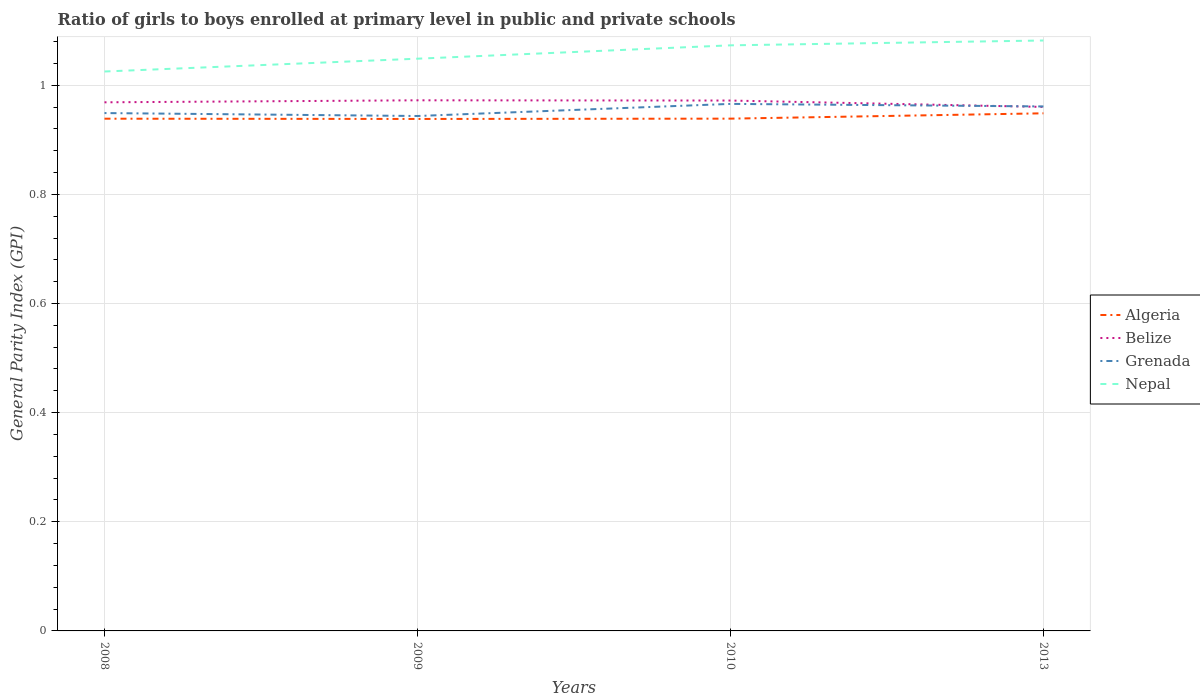Does the line corresponding to Algeria intersect with the line corresponding to Grenada?
Provide a succinct answer. No. Is the number of lines equal to the number of legend labels?
Make the answer very short. Yes. Across all years, what is the maximum general parity index in Nepal?
Your answer should be very brief. 1.03. What is the total general parity index in Grenada in the graph?
Make the answer very short. 0. What is the difference between the highest and the second highest general parity index in Belize?
Give a very brief answer. 0.01. What is the difference between the highest and the lowest general parity index in Nepal?
Offer a very short reply. 2. How many years are there in the graph?
Make the answer very short. 4. Does the graph contain any zero values?
Offer a very short reply. No. Does the graph contain grids?
Provide a short and direct response. Yes. Where does the legend appear in the graph?
Offer a very short reply. Center right. How many legend labels are there?
Offer a terse response. 4. What is the title of the graph?
Offer a very short reply. Ratio of girls to boys enrolled at primary level in public and private schools. Does "Pakistan" appear as one of the legend labels in the graph?
Give a very brief answer. No. What is the label or title of the Y-axis?
Make the answer very short. General Parity Index (GPI). What is the General Parity Index (GPI) in Algeria in 2008?
Offer a terse response. 0.94. What is the General Parity Index (GPI) of Belize in 2008?
Make the answer very short. 0.97. What is the General Parity Index (GPI) in Grenada in 2008?
Your response must be concise. 0.95. What is the General Parity Index (GPI) in Nepal in 2008?
Offer a very short reply. 1.03. What is the General Parity Index (GPI) in Algeria in 2009?
Your answer should be compact. 0.94. What is the General Parity Index (GPI) in Belize in 2009?
Give a very brief answer. 0.97. What is the General Parity Index (GPI) in Grenada in 2009?
Keep it short and to the point. 0.94. What is the General Parity Index (GPI) of Nepal in 2009?
Your answer should be compact. 1.05. What is the General Parity Index (GPI) of Algeria in 2010?
Offer a very short reply. 0.94. What is the General Parity Index (GPI) of Belize in 2010?
Provide a succinct answer. 0.97. What is the General Parity Index (GPI) in Grenada in 2010?
Provide a succinct answer. 0.97. What is the General Parity Index (GPI) in Nepal in 2010?
Offer a very short reply. 1.07. What is the General Parity Index (GPI) of Algeria in 2013?
Your answer should be very brief. 0.95. What is the General Parity Index (GPI) of Belize in 2013?
Keep it short and to the point. 0.96. What is the General Parity Index (GPI) of Grenada in 2013?
Make the answer very short. 0.96. What is the General Parity Index (GPI) of Nepal in 2013?
Provide a short and direct response. 1.08. Across all years, what is the maximum General Parity Index (GPI) of Algeria?
Provide a succinct answer. 0.95. Across all years, what is the maximum General Parity Index (GPI) of Belize?
Your answer should be compact. 0.97. Across all years, what is the maximum General Parity Index (GPI) of Grenada?
Make the answer very short. 0.97. Across all years, what is the maximum General Parity Index (GPI) of Nepal?
Provide a succinct answer. 1.08. Across all years, what is the minimum General Parity Index (GPI) of Algeria?
Give a very brief answer. 0.94. Across all years, what is the minimum General Parity Index (GPI) in Belize?
Your answer should be compact. 0.96. Across all years, what is the minimum General Parity Index (GPI) in Grenada?
Keep it short and to the point. 0.94. Across all years, what is the minimum General Parity Index (GPI) of Nepal?
Make the answer very short. 1.03. What is the total General Parity Index (GPI) in Algeria in the graph?
Your response must be concise. 3.76. What is the total General Parity Index (GPI) in Belize in the graph?
Provide a short and direct response. 3.87. What is the total General Parity Index (GPI) in Grenada in the graph?
Your answer should be compact. 3.82. What is the total General Parity Index (GPI) of Nepal in the graph?
Make the answer very short. 4.23. What is the difference between the General Parity Index (GPI) of Belize in 2008 and that in 2009?
Ensure brevity in your answer.  -0. What is the difference between the General Parity Index (GPI) of Grenada in 2008 and that in 2009?
Your response must be concise. 0.01. What is the difference between the General Parity Index (GPI) of Nepal in 2008 and that in 2009?
Your answer should be compact. -0.02. What is the difference between the General Parity Index (GPI) in Algeria in 2008 and that in 2010?
Your answer should be compact. -0. What is the difference between the General Parity Index (GPI) in Belize in 2008 and that in 2010?
Ensure brevity in your answer.  -0. What is the difference between the General Parity Index (GPI) of Grenada in 2008 and that in 2010?
Ensure brevity in your answer.  -0.02. What is the difference between the General Parity Index (GPI) in Nepal in 2008 and that in 2010?
Keep it short and to the point. -0.05. What is the difference between the General Parity Index (GPI) of Algeria in 2008 and that in 2013?
Ensure brevity in your answer.  -0.01. What is the difference between the General Parity Index (GPI) of Belize in 2008 and that in 2013?
Your response must be concise. 0.01. What is the difference between the General Parity Index (GPI) of Grenada in 2008 and that in 2013?
Provide a short and direct response. -0.01. What is the difference between the General Parity Index (GPI) in Nepal in 2008 and that in 2013?
Offer a terse response. -0.06. What is the difference between the General Parity Index (GPI) in Algeria in 2009 and that in 2010?
Keep it short and to the point. -0. What is the difference between the General Parity Index (GPI) of Grenada in 2009 and that in 2010?
Offer a terse response. -0.02. What is the difference between the General Parity Index (GPI) of Nepal in 2009 and that in 2010?
Your response must be concise. -0.02. What is the difference between the General Parity Index (GPI) in Algeria in 2009 and that in 2013?
Give a very brief answer. -0.01. What is the difference between the General Parity Index (GPI) in Belize in 2009 and that in 2013?
Offer a very short reply. 0.01. What is the difference between the General Parity Index (GPI) in Grenada in 2009 and that in 2013?
Make the answer very short. -0.02. What is the difference between the General Parity Index (GPI) in Nepal in 2009 and that in 2013?
Offer a terse response. -0.03. What is the difference between the General Parity Index (GPI) of Algeria in 2010 and that in 2013?
Keep it short and to the point. -0.01. What is the difference between the General Parity Index (GPI) of Belize in 2010 and that in 2013?
Make the answer very short. 0.01. What is the difference between the General Parity Index (GPI) in Grenada in 2010 and that in 2013?
Your answer should be very brief. 0. What is the difference between the General Parity Index (GPI) of Nepal in 2010 and that in 2013?
Your answer should be compact. -0.01. What is the difference between the General Parity Index (GPI) of Algeria in 2008 and the General Parity Index (GPI) of Belize in 2009?
Ensure brevity in your answer.  -0.03. What is the difference between the General Parity Index (GPI) in Algeria in 2008 and the General Parity Index (GPI) in Grenada in 2009?
Keep it short and to the point. -0. What is the difference between the General Parity Index (GPI) of Algeria in 2008 and the General Parity Index (GPI) of Nepal in 2009?
Provide a succinct answer. -0.11. What is the difference between the General Parity Index (GPI) of Belize in 2008 and the General Parity Index (GPI) of Grenada in 2009?
Your answer should be compact. 0.03. What is the difference between the General Parity Index (GPI) in Belize in 2008 and the General Parity Index (GPI) in Nepal in 2009?
Ensure brevity in your answer.  -0.08. What is the difference between the General Parity Index (GPI) of Grenada in 2008 and the General Parity Index (GPI) of Nepal in 2009?
Provide a short and direct response. -0.1. What is the difference between the General Parity Index (GPI) of Algeria in 2008 and the General Parity Index (GPI) of Belize in 2010?
Give a very brief answer. -0.03. What is the difference between the General Parity Index (GPI) in Algeria in 2008 and the General Parity Index (GPI) in Grenada in 2010?
Offer a very short reply. -0.03. What is the difference between the General Parity Index (GPI) of Algeria in 2008 and the General Parity Index (GPI) of Nepal in 2010?
Offer a terse response. -0.13. What is the difference between the General Parity Index (GPI) of Belize in 2008 and the General Parity Index (GPI) of Grenada in 2010?
Provide a succinct answer. 0. What is the difference between the General Parity Index (GPI) of Belize in 2008 and the General Parity Index (GPI) of Nepal in 2010?
Keep it short and to the point. -0.1. What is the difference between the General Parity Index (GPI) in Grenada in 2008 and the General Parity Index (GPI) in Nepal in 2010?
Keep it short and to the point. -0.12. What is the difference between the General Parity Index (GPI) in Algeria in 2008 and the General Parity Index (GPI) in Belize in 2013?
Provide a short and direct response. -0.02. What is the difference between the General Parity Index (GPI) of Algeria in 2008 and the General Parity Index (GPI) of Grenada in 2013?
Offer a very short reply. -0.02. What is the difference between the General Parity Index (GPI) in Algeria in 2008 and the General Parity Index (GPI) in Nepal in 2013?
Your response must be concise. -0.14. What is the difference between the General Parity Index (GPI) in Belize in 2008 and the General Parity Index (GPI) in Grenada in 2013?
Provide a short and direct response. 0.01. What is the difference between the General Parity Index (GPI) of Belize in 2008 and the General Parity Index (GPI) of Nepal in 2013?
Offer a terse response. -0.11. What is the difference between the General Parity Index (GPI) in Grenada in 2008 and the General Parity Index (GPI) in Nepal in 2013?
Offer a terse response. -0.13. What is the difference between the General Parity Index (GPI) of Algeria in 2009 and the General Parity Index (GPI) of Belize in 2010?
Ensure brevity in your answer.  -0.03. What is the difference between the General Parity Index (GPI) in Algeria in 2009 and the General Parity Index (GPI) in Grenada in 2010?
Your answer should be compact. -0.03. What is the difference between the General Parity Index (GPI) in Algeria in 2009 and the General Parity Index (GPI) in Nepal in 2010?
Ensure brevity in your answer.  -0.13. What is the difference between the General Parity Index (GPI) in Belize in 2009 and the General Parity Index (GPI) in Grenada in 2010?
Provide a succinct answer. 0.01. What is the difference between the General Parity Index (GPI) of Belize in 2009 and the General Parity Index (GPI) of Nepal in 2010?
Provide a succinct answer. -0.1. What is the difference between the General Parity Index (GPI) in Grenada in 2009 and the General Parity Index (GPI) in Nepal in 2010?
Offer a very short reply. -0.13. What is the difference between the General Parity Index (GPI) of Algeria in 2009 and the General Parity Index (GPI) of Belize in 2013?
Offer a terse response. -0.02. What is the difference between the General Parity Index (GPI) in Algeria in 2009 and the General Parity Index (GPI) in Grenada in 2013?
Make the answer very short. -0.02. What is the difference between the General Parity Index (GPI) in Algeria in 2009 and the General Parity Index (GPI) in Nepal in 2013?
Provide a succinct answer. -0.14. What is the difference between the General Parity Index (GPI) in Belize in 2009 and the General Parity Index (GPI) in Grenada in 2013?
Make the answer very short. 0.01. What is the difference between the General Parity Index (GPI) in Belize in 2009 and the General Parity Index (GPI) in Nepal in 2013?
Your response must be concise. -0.11. What is the difference between the General Parity Index (GPI) of Grenada in 2009 and the General Parity Index (GPI) of Nepal in 2013?
Keep it short and to the point. -0.14. What is the difference between the General Parity Index (GPI) in Algeria in 2010 and the General Parity Index (GPI) in Belize in 2013?
Ensure brevity in your answer.  -0.02. What is the difference between the General Parity Index (GPI) in Algeria in 2010 and the General Parity Index (GPI) in Grenada in 2013?
Provide a succinct answer. -0.02. What is the difference between the General Parity Index (GPI) in Algeria in 2010 and the General Parity Index (GPI) in Nepal in 2013?
Provide a succinct answer. -0.14. What is the difference between the General Parity Index (GPI) of Belize in 2010 and the General Parity Index (GPI) of Grenada in 2013?
Offer a very short reply. 0.01. What is the difference between the General Parity Index (GPI) of Belize in 2010 and the General Parity Index (GPI) of Nepal in 2013?
Offer a very short reply. -0.11. What is the difference between the General Parity Index (GPI) in Grenada in 2010 and the General Parity Index (GPI) in Nepal in 2013?
Make the answer very short. -0.12. What is the average General Parity Index (GPI) in Algeria per year?
Provide a succinct answer. 0.94. What is the average General Parity Index (GPI) of Belize per year?
Your answer should be very brief. 0.97. What is the average General Parity Index (GPI) of Grenada per year?
Ensure brevity in your answer.  0.95. What is the average General Parity Index (GPI) in Nepal per year?
Provide a short and direct response. 1.06. In the year 2008, what is the difference between the General Parity Index (GPI) of Algeria and General Parity Index (GPI) of Belize?
Provide a short and direct response. -0.03. In the year 2008, what is the difference between the General Parity Index (GPI) of Algeria and General Parity Index (GPI) of Grenada?
Make the answer very short. -0.01. In the year 2008, what is the difference between the General Parity Index (GPI) in Algeria and General Parity Index (GPI) in Nepal?
Make the answer very short. -0.09. In the year 2008, what is the difference between the General Parity Index (GPI) of Belize and General Parity Index (GPI) of Grenada?
Your answer should be very brief. 0.02. In the year 2008, what is the difference between the General Parity Index (GPI) in Belize and General Parity Index (GPI) in Nepal?
Your response must be concise. -0.06. In the year 2008, what is the difference between the General Parity Index (GPI) in Grenada and General Parity Index (GPI) in Nepal?
Keep it short and to the point. -0.08. In the year 2009, what is the difference between the General Parity Index (GPI) of Algeria and General Parity Index (GPI) of Belize?
Your response must be concise. -0.03. In the year 2009, what is the difference between the General Parity Index (GPI) of Algeria and General Parity Index (GPI) of Grenada?
Make the answer very short. -0.01. In the year 2009, what is the difference between the General Parity Index (GPI) of Algeria and General Parity Index (GPI) of Nepal?
Ensure brevity in your answer.  -0.11. In the year 2009, what is the difference between the General Parity Index (GPI) of Belize and General Parity Index (GPI) of Grenada?
Provide a short and direct response. 0.03. In the year 2009, what is the difference between the General Parity Index (GPI) in Belize and General Parity Index (GPI) in Nepal?
Your answer should be very brief. -0.08. In the year 2009, what is the difference between the General Parity Index (GPI) of Grenada and General Parity Index (GPI) of Nepal?
Your answer should be very brief. -0.1. In the year 2010, what is the difference between the General Parity Index (GPI) of Algeria and General Parity Index (GPI) of Belize?
Provide a short and direct response. -0.03. In the year 2010, what is the difference between the General Parity Index (GPI) in Algeria and General Parity Index (GPI) in Grenada?
Make the answer very short. -0.03. In the year 2010, what is the difference between the General Parity Index (GPI) of Algeria and General Parity Index (GPI) of Nepal?
Offer a terse response. -0.13. In the year 2010, what is the difference between the General Parity Index (GPI) in Belize and General Parity Index (GPI) in Grenada?
Keep it short and to the point. 0.01. In the year 2010, what is the difference between the General Parity Index (GPI) of Belize and General Parity Index (GPI) of Nepal?
Ensure brevity in your answer.  -0.1. In the year 2010, what is the difference between the General Parity Index (GPI) in Grenada and General Parity Index (GPI) in Nepal?
Provide a succinct answer. -0.11. In the year 2013, what is the difference between the General Parity Index (GPI) in Algeria and General Parity Index (GPI) in Belize?
Keep it short and to the point. -0.01. In the year 2013, what is the difference between the General Parity Index (GPI) of Algeria and General Parity Index (GPI) of Grenada?
Make the answer very short. -0.01. In the year 2013, what is the difference between the General Parity Index (GPI) in Algeria and General Parity Index (GPI) in Nepal?
Keep it short and to the point. -0.13. In the year 2013, what is the difference between the General Parity Index (GPI) in Belize and General Parity Index (GPI) in Grenada?
Keep it short and to the point. -0. In the year 2013, what is the difference between the General Parity Index (GPI) of Belize and General Parity Index (GPI) of Nepal?
Your response must be concise. -0.12. In the year 2013, what is the difference between the General Parity Index (GPI) in Grenada and General Parity Index (GPI) in Nepal?
Give a very brief answer. -0.12. What is the ratio of the General Parity Index (GPI) in Grenada in 2008 to that in 2009?
Your answer should be very brief. 1.01. What is the ratio of the General Parity Index (GPI) in Nepal in 2008 to that in 2009?
Give a very brief answer. 0.98. What is the ratio of the General Parity Index (GPI) in Algeria in 2008 to that in 2010?
Provide a short and direct response. 1. What is the ratio of the General Parity Index (GPI) of Belize in 2008 to that in 2010?
Ensure brevity in your answer.  1. What is the ratio of the General Parity Index (GPI) of Grenada in 2008 to that in 2010?
Offer a terse response. 0.98. What is the ratio of the General Parity Index (GPI) of Nepal in 2008 to that in 2010?
Ensure brevity in your answer.  0.96. What is the ratio of the General Parity Index (GPI) of Algeria in 2008 to that in 2013?
Your response must be concise. 0.99. What is the ratio of the General Parity Index (GPI) in Belize in 2008 to that in 2013?
Your response must be concise. 1.01. What is the ratio of the General Parity Index (GPI) in Grenada in 2008 to that in 2013?
Provide a succinct answer. 0.99. What is the ratio of the General Parity Index (GPI) of Nepal in 2008 to that in 2013?
Ensure brevity in your answer.  0.95. What is the ratio of the General Parity Index (GPI) of Belize in 2009 to that in 2010?
Offer a very short reply. 1. What is the ratio of the General Parity Index (GPI) in Grenada in 2009 to that in 2010?
Give a very brief answer. 0.98. What is the ratio of the General Parity Index (GPI) of Nepal in 2009 to that in 2010?
Offer a very short reply. 0.98. What is the ratio of the General Parity Index (GPI) of Belize in 2009 to that in 2013?
Ensure brevity in your answer.  1.01. What is the ratio of the General Parity Index (GPI) in Grenada in 2009 to that in 2013?
Keep it short and to the point. 0.98. What is the ratio of the General Parity Index (GPI) in Nepal in 2009 to that in 2013?
Provide a short and direct response. 0.97. What is the ratio of the General Parity Index (GPI) of Algeria in 2010 to that in 2013?
Offer a terse response. 0.99. What is the ratio of the General Parity Index (GPI) of Belize in 2010 to that in 2013?
Provide a succinct answer. 1.01. What is the ratio of the General Parity Index (GPI) of Nepal in 2010 to that in 2013?
Your answer should be compact. 0.99. What is the difference between the highest and the second highest General Parity Index (GPI) of Algeria?
Make the answer very short. 0.01. What is the difference between the highest and the second highest General Parity Index (GPI) of Grenada?
Your answer should be compact. 0. What is the difference between the highest and the second highest General Parity Index (GPI) in Nepal?
Offer a terse response. 0.01. What is the difference between the highest and the lowest General Parity Index (GPI) of Algeria?
Offer a terse response. 0.01. What is the difference between the highest and the lowest General Parity Index (GPI) in Belize?
Provide a succinct answer. 0.01. What is the difference between the highest and the lowest General Parity Index (GPI) in Grenada?
Offer a very short reply. 0.02. What is the difference between the highest and the lowest General Parity Index (GPI) in Nepal?
Your answer should be compact. 0.06. 